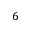<formula> <loc_0><loc_0><loc_500><loc_500>6</formula> 